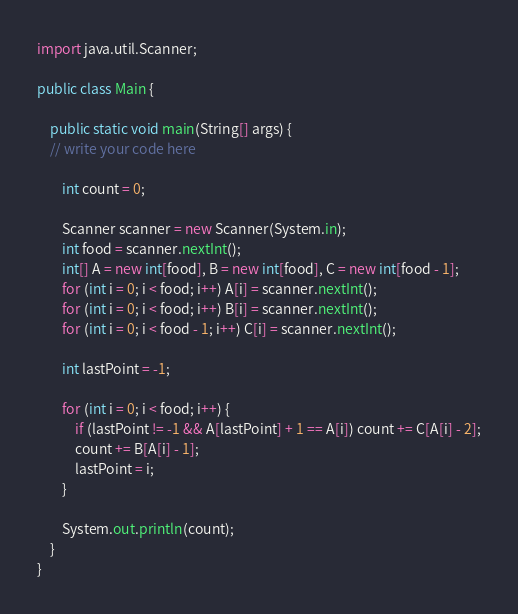<code> <loc_0><loc_0><loc_500><loc_500><_Java_>import java.util.Scanner;

public class Main {

    public static void main(String[] args) {
	// write your code here

        int count = 0;

        Scanner scanner = new Scanner(System.in);
        int food = scanner.nextInt();
        int[] A = new int[food], B = new int[food], C = new int[food - 1];
        for (int i = 0; i < food; i++) A[i] = scanner.nextInt();
        for (int i = 0; i < food; i++) B[i] = scanner.nextInt();
        for (int i = 0; i < food - 1; i++) C[i] = scanner.nextInt();

        int lastPoint = -1;

        for (int i = 0; i < food; i++) {
            if (lastPoint != -1 && A[lastPoint] + 1 == A[i]) count += C[A[i] - 2];
            count += B[A[i] - 1];
            lastPoint = i;
        }

        System.out.println(count);
    }
}
</code> 